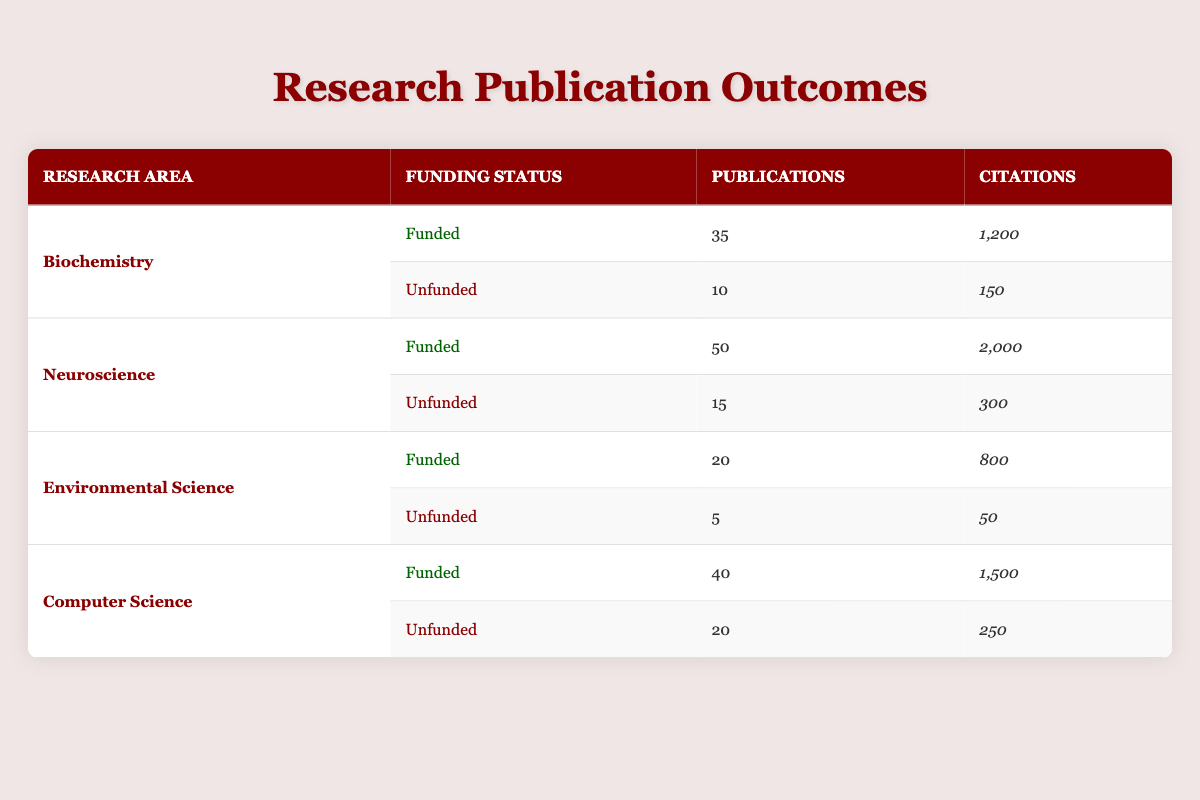What is the total number of publications for funded research areas? To find the total, we sum the publications for all funded research areas. Biochemistry has 35, Neuroscience has 50, Environmental Science has 20, and Computer Science has 40. So, the total is 35 + 50 + 20 + 40 = 145.
Answer: 145 What is the funding status of the research area with the highest number of citations? Looking at the citations, Neuroscience has the highest at 2,000. The funding status for Neuroscience is 'Funded'.
Answer: Funded Which research area has the lowest number of publications overall? The lowest number of publications can be found by evaluating all the rows. Environmental Science with 'Unfunded' has only 5 publications, which is the lowest in the table.
Answer: Environmental Science (Unfunded) What percentage of publications from the Computer Science area are funded? Computer Science has 40 funded publications and 20 unfunded publications for a total of 60. The percentage is calculated as (40/60) * 100 = 66.67%.
Answer: 66.67% Is it true that unfunded research areas have more publications than funded ones in at least one research area? Evaluating the data, in the Environmental Science area, unfunded has 5 publications, while funded has 20. No unfunded area has more than funded areas. Therefore, it is false.
Answer: False What is the average number of citations for unfunded research areas? For unfunded areas, we have 150 (Biochemistry) + 300 (Neuroscience) + 50 (Environmental Science) + 250 (Computer Science), which totals to 750 citations for 4 studies. To find the average, divide 750 by 4, which equals 187.5.
Answer: 187.5 How many total citations do funded research areas have compared to unfunded research areas? Funded areas’ citations are 1,200 (Biochemistry) + 2,000 (Neuroscience) + 800 (Environmental Science) + 1,500 (Computer Science) totaling 5,500. Unfunded areas’ citations total 150 + 300 + 50 + 250 which equals 750. Therefore, funded areas have 5,500 citations compared to unfunded's 750.
Answer: Funded: 5,500, Unfunded: 750 Which research area is the most prolific in terms of publications and what is the funding status? Evaluating the number of publications, Neuroscience has 50, which is the highest. It is 'Funded'.
Answer: Neuroscience, Funded 